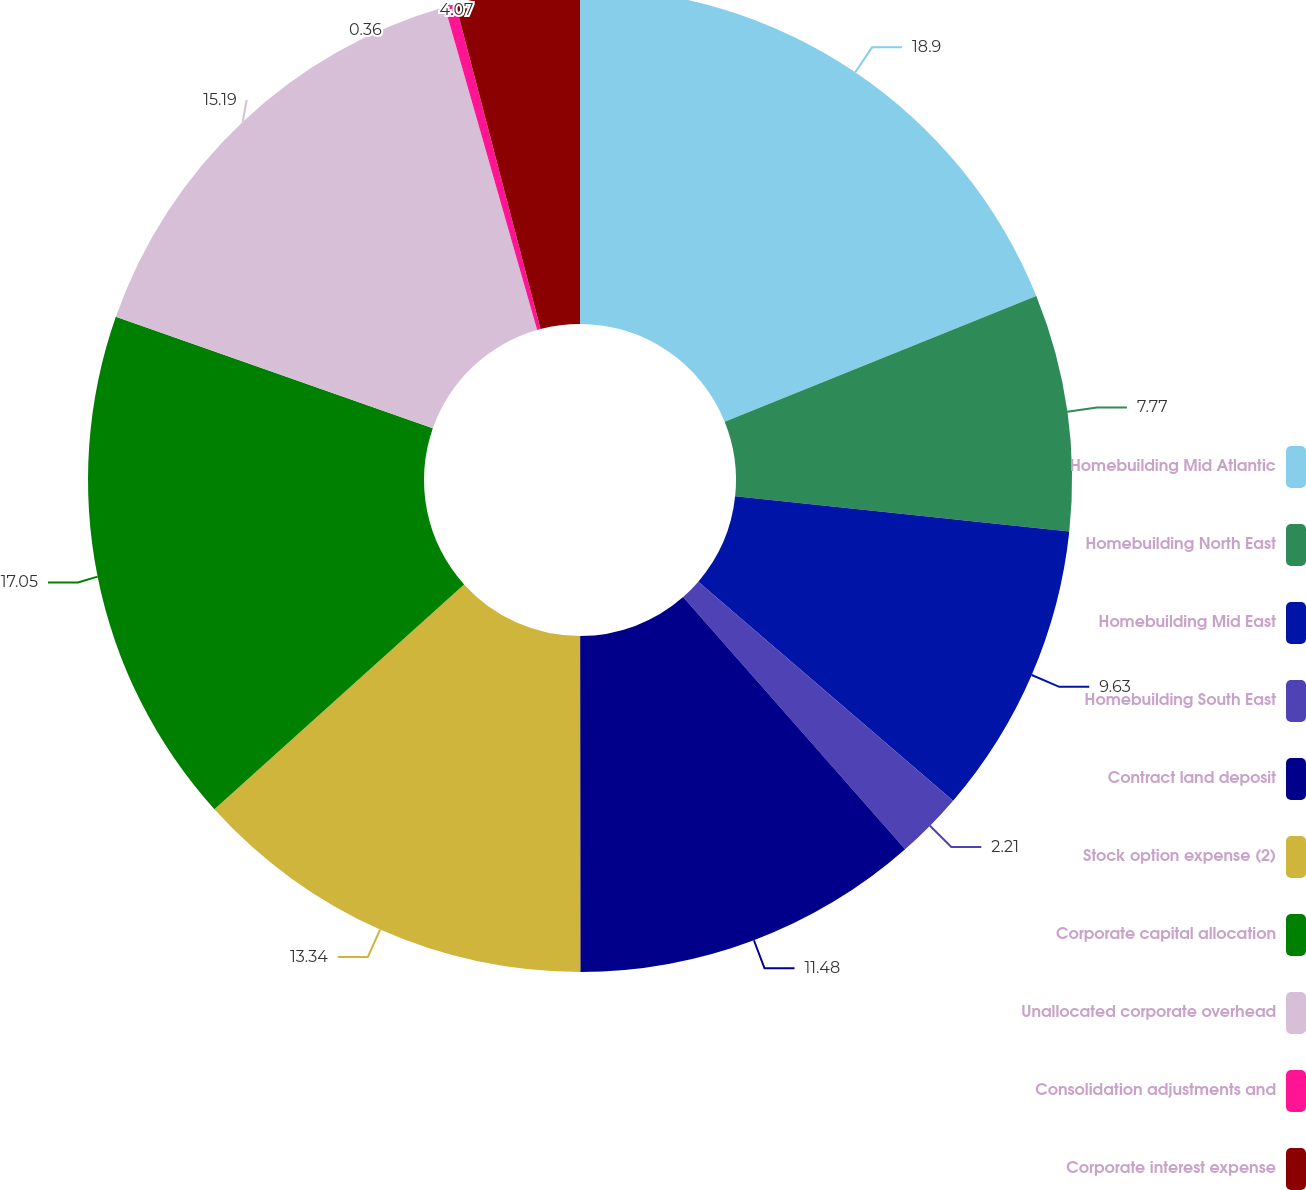Convert chart. <chart><loc_0><loc_0><loc_500><loc_500><pie_chart><fcel>Homebuilding Mid Atlantic<fcel>Homebuilding North East<fcel>Homebuilding Mid East<fcel>Homebuilding South East<fcel>Contract land deposit<fcel>Stock option expense (2)<fcel>Corporate capital allocation<fcel>Unallocated corporate overhead<fcel>Consolidation adjustments and<fcel>Corporate interest expense<nl><fcel>18.9%<fcel>7.77%<fcel>9.63%<fcel>2.21%<fcel>11.48%<fcel>13.34%<fcel>17.05%<fcel>15.19%<fcel>0.36%<fcel>4.07%<nl></chart> 